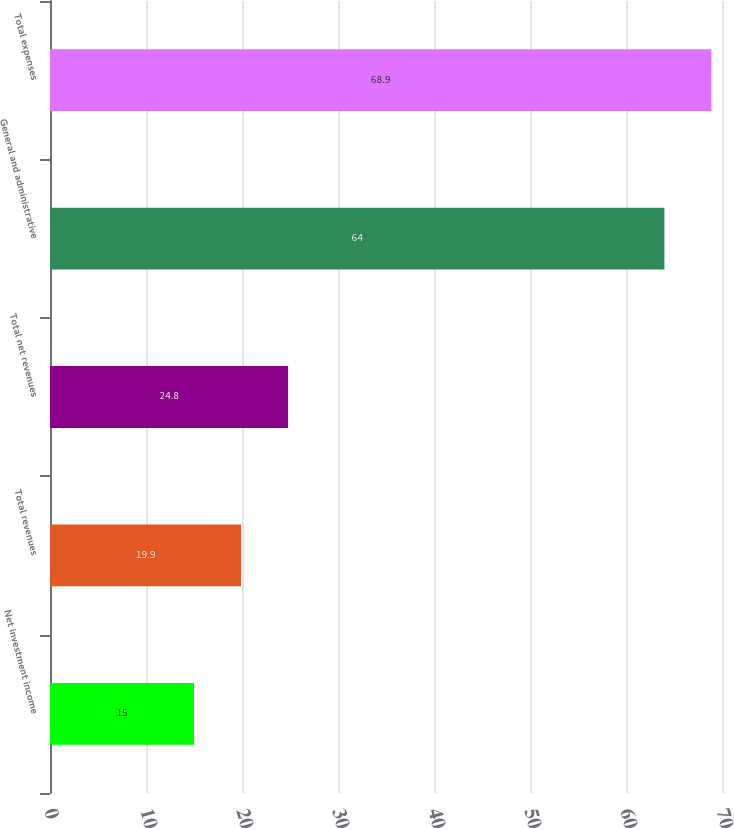Convert chart to OTSL. <chart><loc_0><loc_0><loc_500><loc_500><bar_chart><fcel>Net investment income<fcel>Total revenues<fcel>Total net revenues<fcel>General and administrative<fcel>Total expenses<nl><fcel>15<fcel>19.9<fcel>24.8<fcel>64<fcel>68.9<nl></chart> 